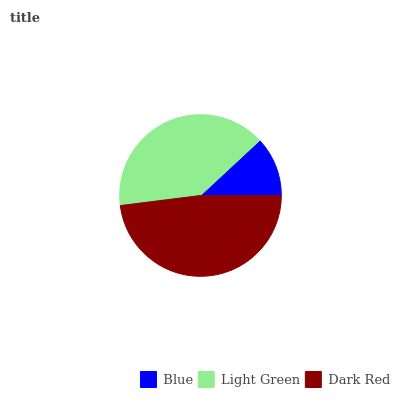Is Blue the minimum?
Answer yes or no. Yes. Is Dark Red the maximum?
Answer yes or no. Yes. Is Light Green the minimum?
Answer yes or no. No. Is Light Green the maximum?
Answer yes or no. No. Is Light Green greater than Blue?
Answer yes or no. Yes. Is Blue less than Light Green?
Answer yes or no. Yes. Is Blue greater than Light Green?
Answer yes or no. No. Is Light Green less than Blue?
Answer yes or no. No. Is Light Green the high median?
Answer yes or no. Yes. Is Light Green the low median?
Answer yes or no. Yes. Is Dark Red the high median?
Answer yes or no. No. Is Blue the low median?
Answer yes or no. No. 